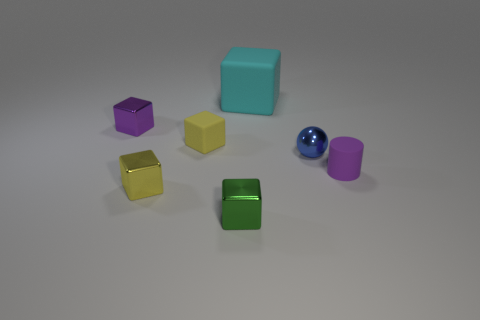Subtract all tiny yellow matte blocks. How many blocks are left? 4 Subtract all green blocks. How many blocks are left? 4 Subtract all blue blocks. Subtract all purple spheres. How many blocks are left? 5 Add 1 purple shiny cubes. How many objects exist? 8 Subtract all cylinders. How many objects are left? 6 Subtract all small yellow things. Subtract all small blue metallic objects. How many objects are left? 4 Add 7 large matte objects. How many large matte objects are left? 8 Add 3 tiny yellow metallic objects. How many tiny yellow metallic objects exist? 4 Subtract 0 blue cylinders. How many objects are left? 7 